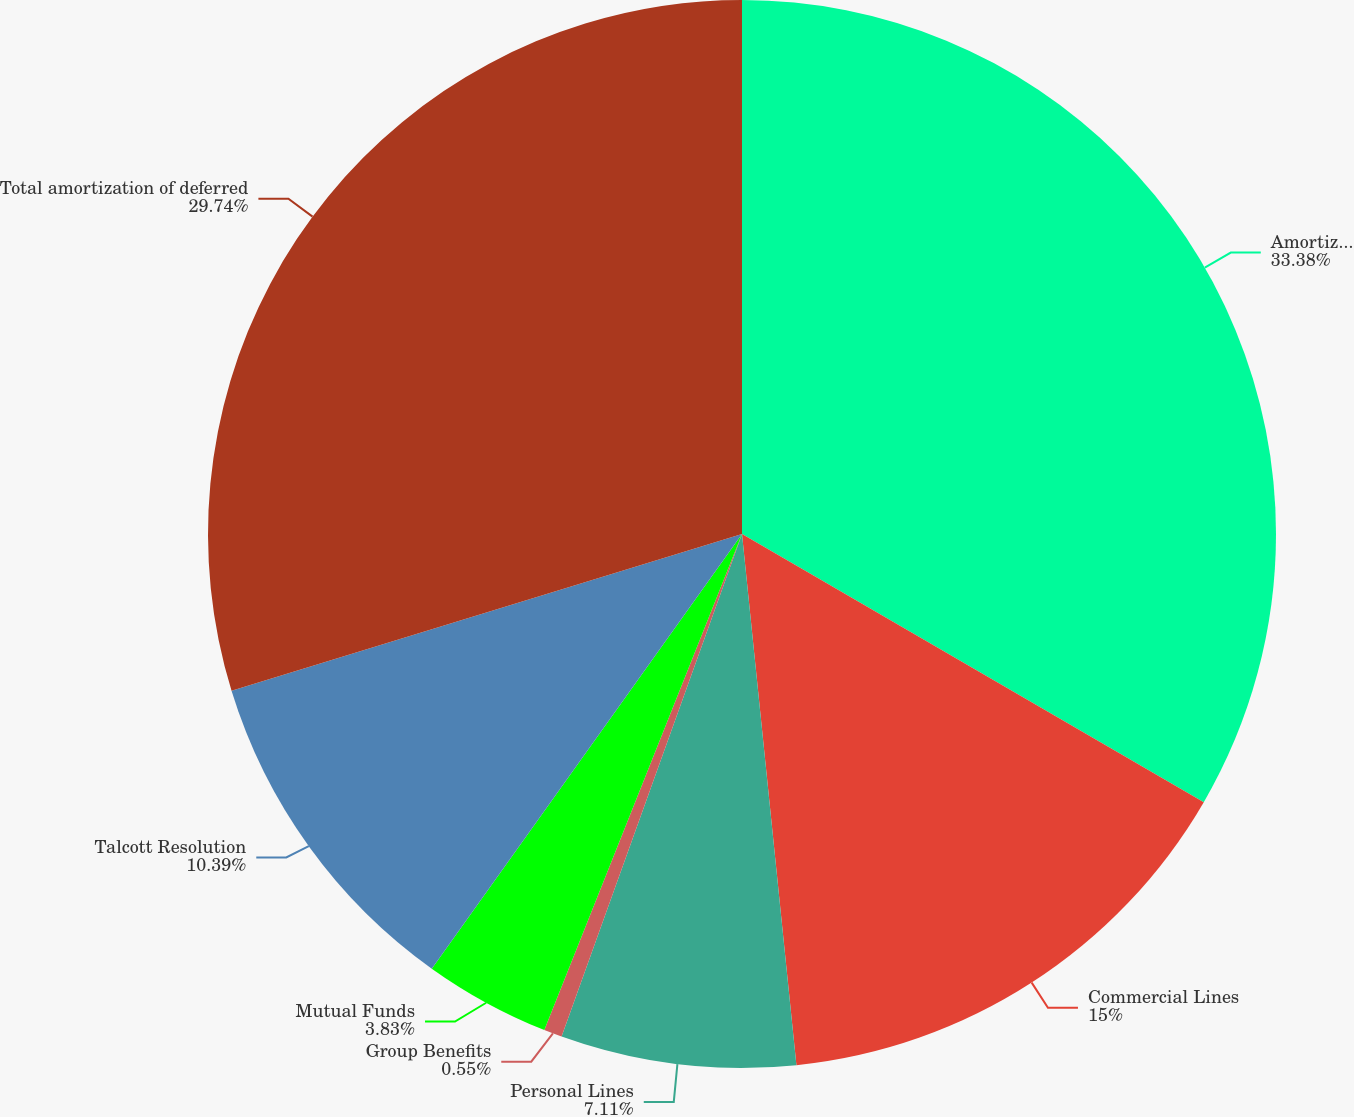<chart> <loc_0><loc_0><loc_500><loc_500><pie_chart><fcel>Amortization of deferred<fcel>Commercial Lines<fcel>Personal Lines<fcel>Group Benefits<fcel>Mutual Funds<fcel>Talcott Resolution<fcel>Total amortization of deferred<nl><fcel>33.37%<fcel>15.0%<fcel>7.11%<fcel>0.55%<fcel>3.83%<fcel>10.39%<fcel>29.74%<nl></chart> 